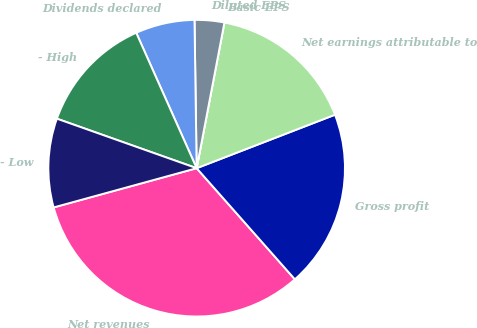Convert chart. <chart><loc_0><loc_0><loc_500><loc_500><pie_chart><fcel>Net revenues<fcel>Gross profit<fcel>Net earnings attributable to<fcel>Basic EPS<fcel>Diluted EPS<fcel>Dividends declared<fcel>- High<fcel>- Low<nl><fcel>32.26%<fcel>19.35%<fcel>16.13%<fcel>0.0%<fcel>3.23%<fcel>6.45%<fcel>12.9%<fcel>9.68%<nl></chart> 